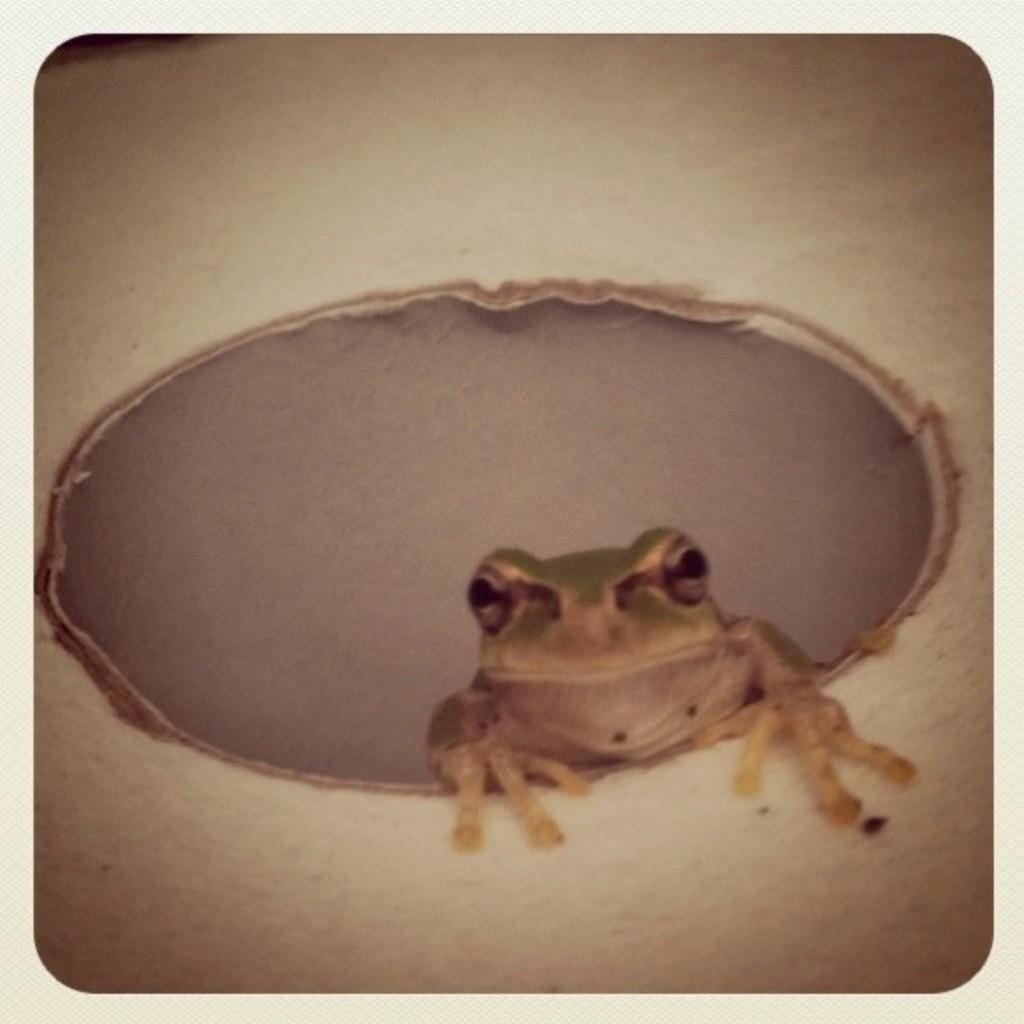What type of animal is in the picture? There is a frog in the picture. What type of knowledge does the fireman have about the brake in the image? There is no fireman or brake present in the image, as it only features a frog. 